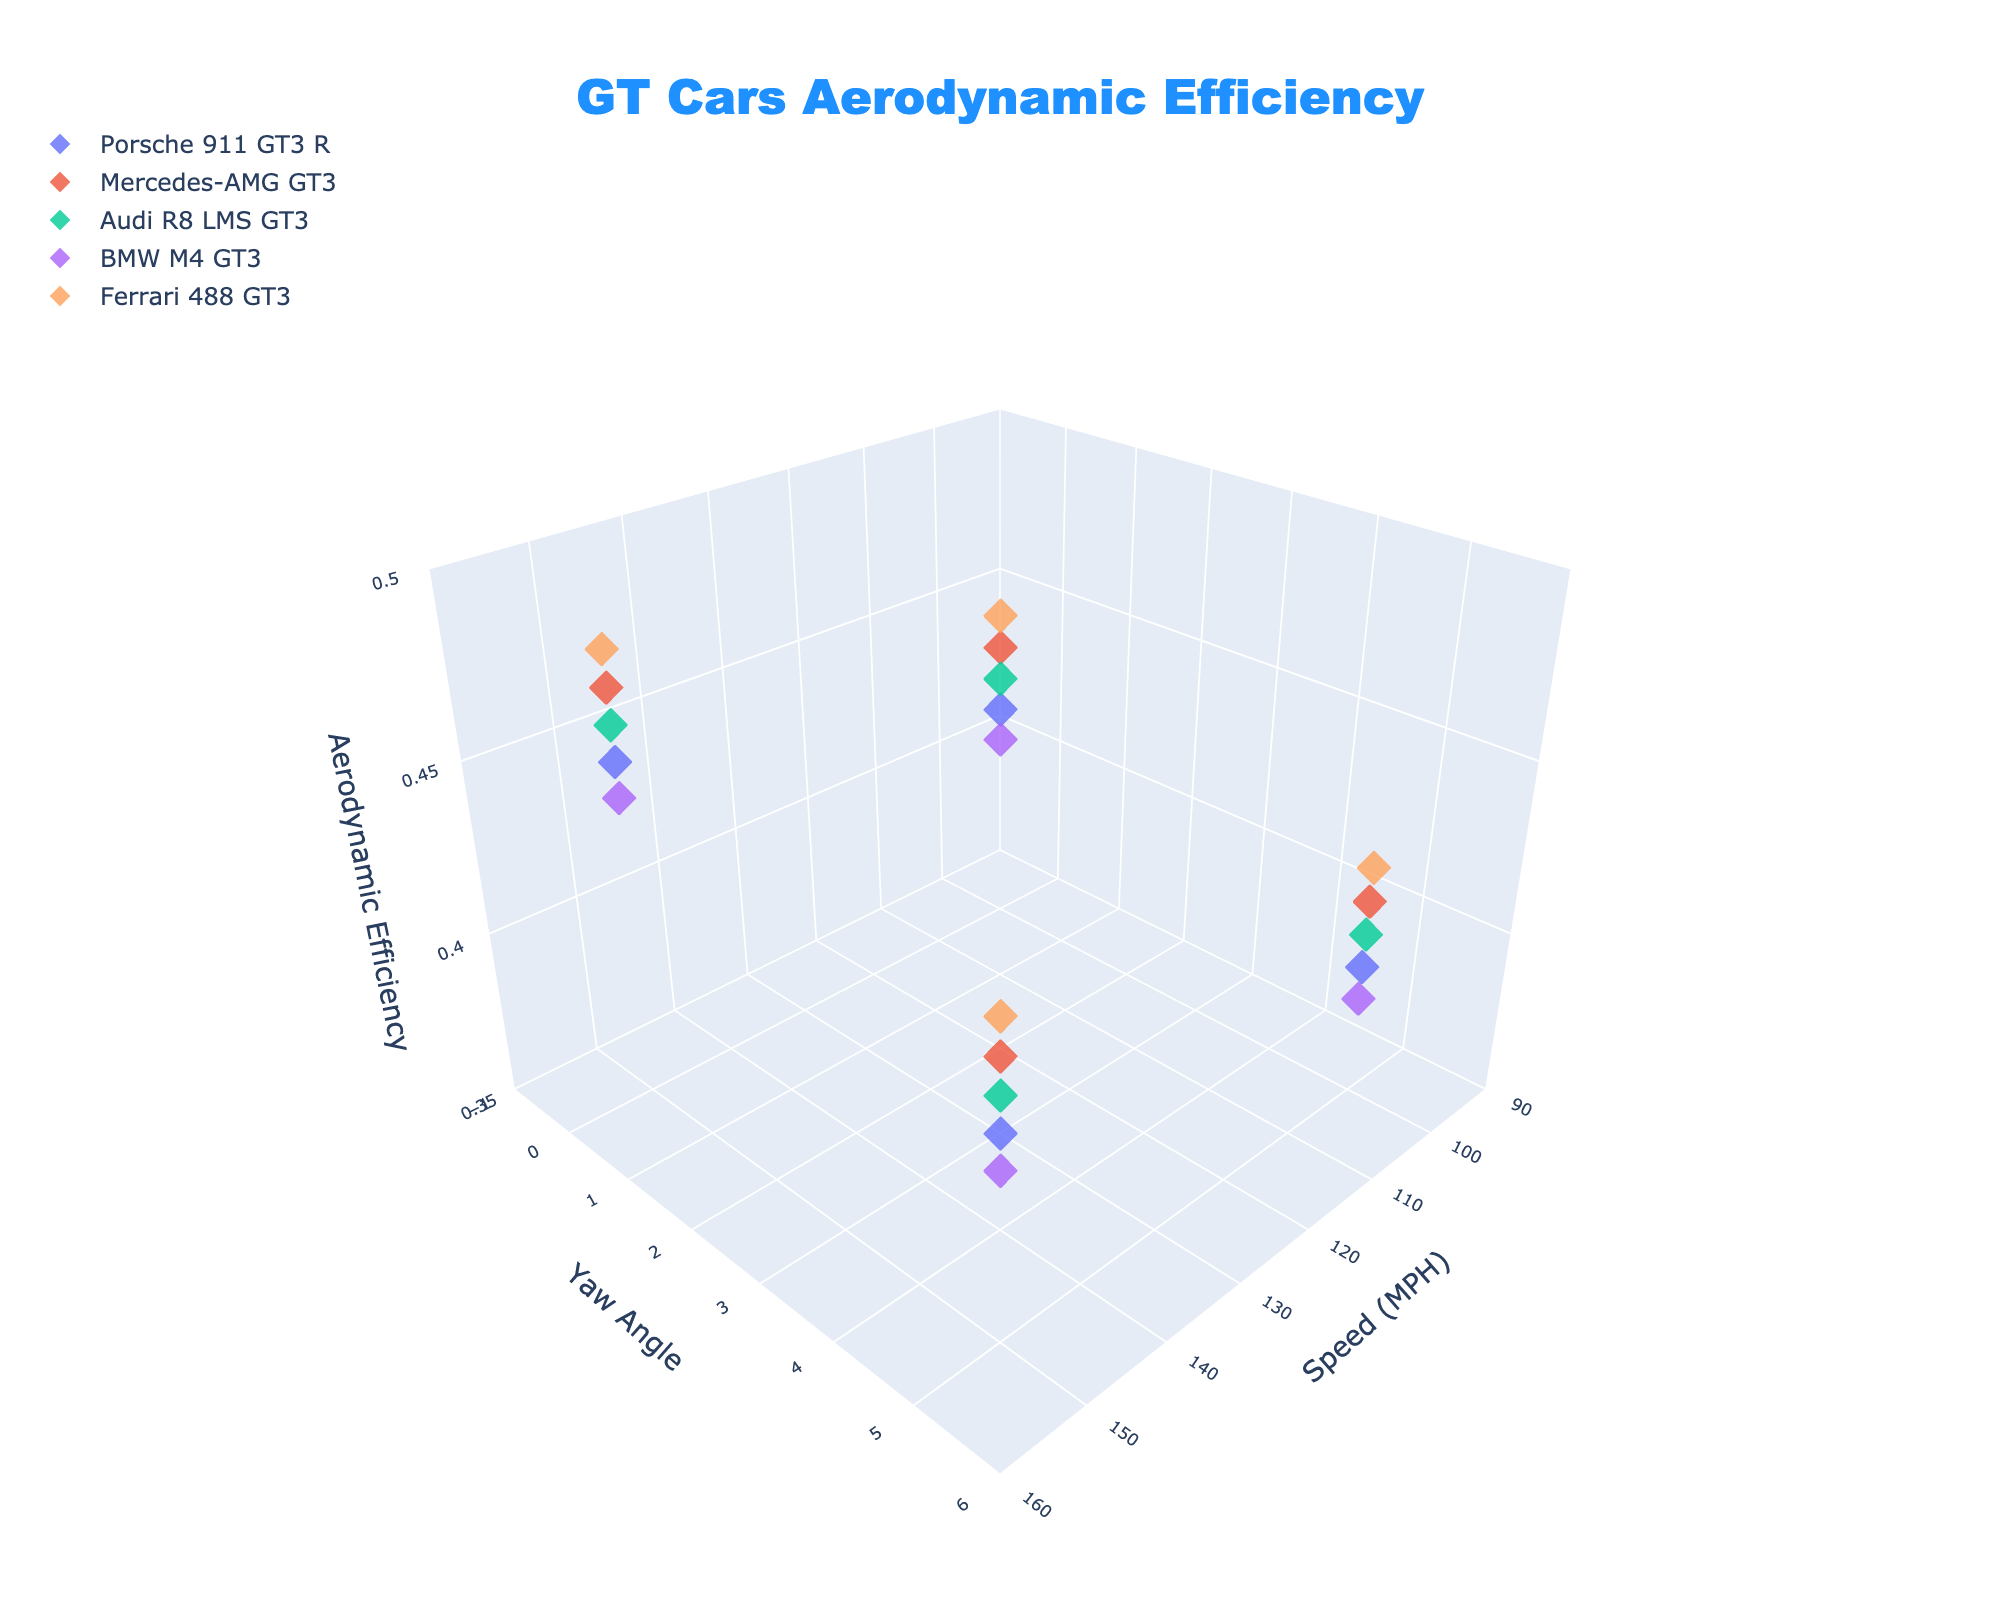What's the title of the figure? The title is shown at the top center of the figure. It reads "GT Cars Aerodynamic Efficiency".
Answer: GT Cars Aerodynamic Efficiency Which car model has the lowest aerodynamic efficiency at 150 MPH and a yaw angle of 0 degrees? Look at the data points or hover over them for the specified speed and yaw angle to find the aerodynamic efficiency for each car model. The BMW M4 GT3 has the lowest aerodynamic efficiency of 0.44.
Answer: BMW M4 GT3 How does the aerodynamic efficiency of the Porsche 911 GT3 R compare between 100 MPH at 0 degrees and 100 MPH at 5 degrees yaw angle? Check the aerodynamic efficiency values for the Porsche 911 GT3 R at the two specified conditions. At 100 MPH and 0 degrees yaw, it's 0.42, and at 100 MPH and 5 degrees yaw, it's 0.39. The efficiency decreases by 0.03 at the higher yaw angle.
Answer: Decreases by 0.03 Which car model shows the highest aerodynamic efficiency at any speed and yaw angle combination? Find the maximum aerodynamic efficiency value across all models and conditions. The Ferrari 488 GT3 shows the highest efficiency of 0.48 at 150 MPH and 0 degrees yaw.
Answer: Ferrari 488 GT3 What is the range of yaw angles depicted in the figure? Look at the y-axis which represents the yaw angle. The yaw angles range from 0 to 5 degrees.
Answer: 0 to 5 degrees What is the average aerodynamic efficiency of the Mercedes-AMG GT3 at 150 MPH? Check the two aerodynamic efficiency values for the Mercedes-AMG GT3 at 150 MPH (0 degrees and 5 degrees yaw), which are 0.47 and 0.43. Calculate the average: (0.47 + 0.43) / 2 = 0.45.
Answer: 0.45 How does increasing speed from 100 MPH to 150 MPH affect the aerodynamic efficiency of the Audi R8 LMS GT3 at 0 degrees yaw angle? Compare the aerodynamic efficiency values for the Audi R8 LMS GT3 at 100 MPH (0.43) and at 150 MPH (0.46) and see if it increases, decreases, or stays the same. The efficiency increases by 0.03.
Answer: Increases by 0.03 Which car model has the most consistent aerodynamic efficiency across all measured speeds and yaw angles? Review the scatter plot to identify the model with the smallest variation in aerodynamic efficiency values. The BMW M4 GT3 shows little fluctuation, varying between 0.38 and 0.44.
Answer: BMW M4 GT3 Is there a general trend in aerodynamic efficiency concerning yaw angle for most car models? Observe the overall trend of aerodynamic efficiency values as the yaw angle increases from 0 to 5 degrees for most car models. It generally decreases.
Answer: Generally decreases What are the speed and yaw angle of the data point with the lowest aerodynamic efficiency for the Ferrari 488 GT3? Identify the lowest aerodynamic efficiency value for the Ferrari 488 GT3 and check its corresponding speed and yaw angle. The lowest efficiency (0.42) occurs at 100 MPH and 5 degrees yaw angle.
Answer: 100 MPH and 5 degrees yaw 